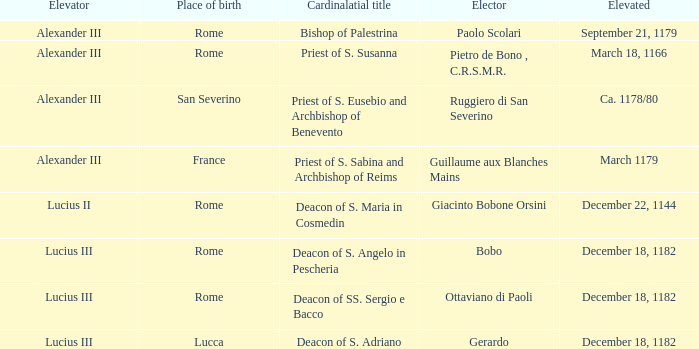Who is the Elector with a Cardinalatial title of Priest of S. Sabina and Archbishop of Reims? Guillaume aux Blanches Mains. 